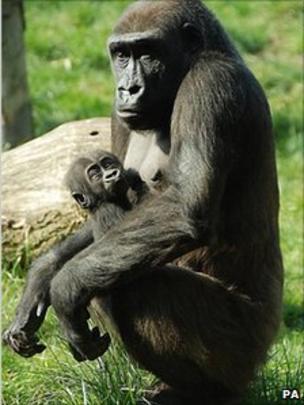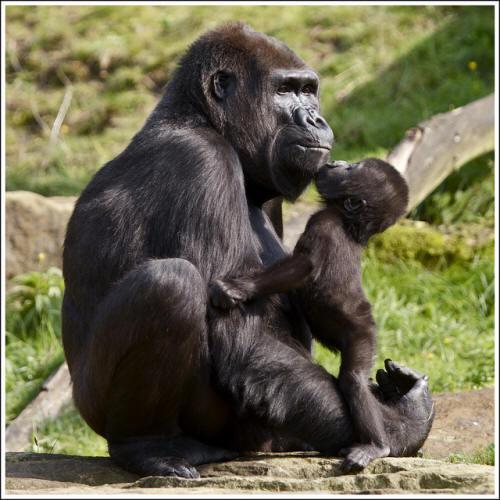The first image is the image on the left, the second image is the image on the right. Assess this claim about the two images: "Two of the apes are posed in contact and face to face, but neither is held off the ground by the other.". Correct or not? Answer yes or no. Yes. The first image is the image on the left, the second image is the image on the right. Analyze the images presented: Is the assertion "A baby gorilla is with an adult gorilla in at least one of the images." valid? Answer yes or no. Yes. 